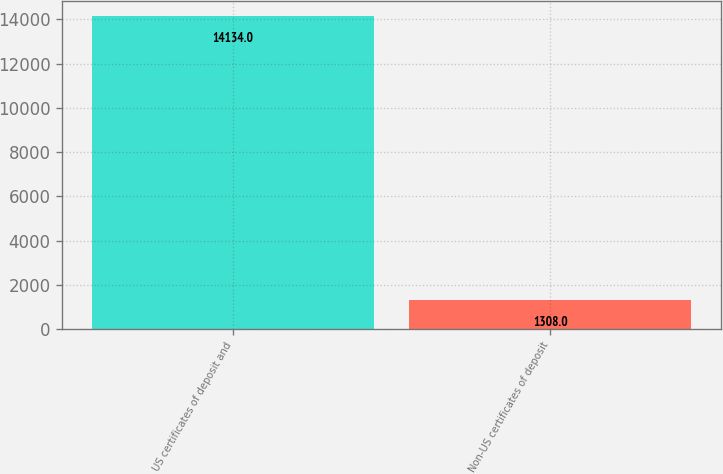Convert chart to OTSL. <chart><loc_0><loc_0><loc_500><loc_500><bar_chart><fcel>US certificates of deposit and<fcel>Non-US certificates of deposit<nl><fcel>14134<fcel>1308<nl></chart> 